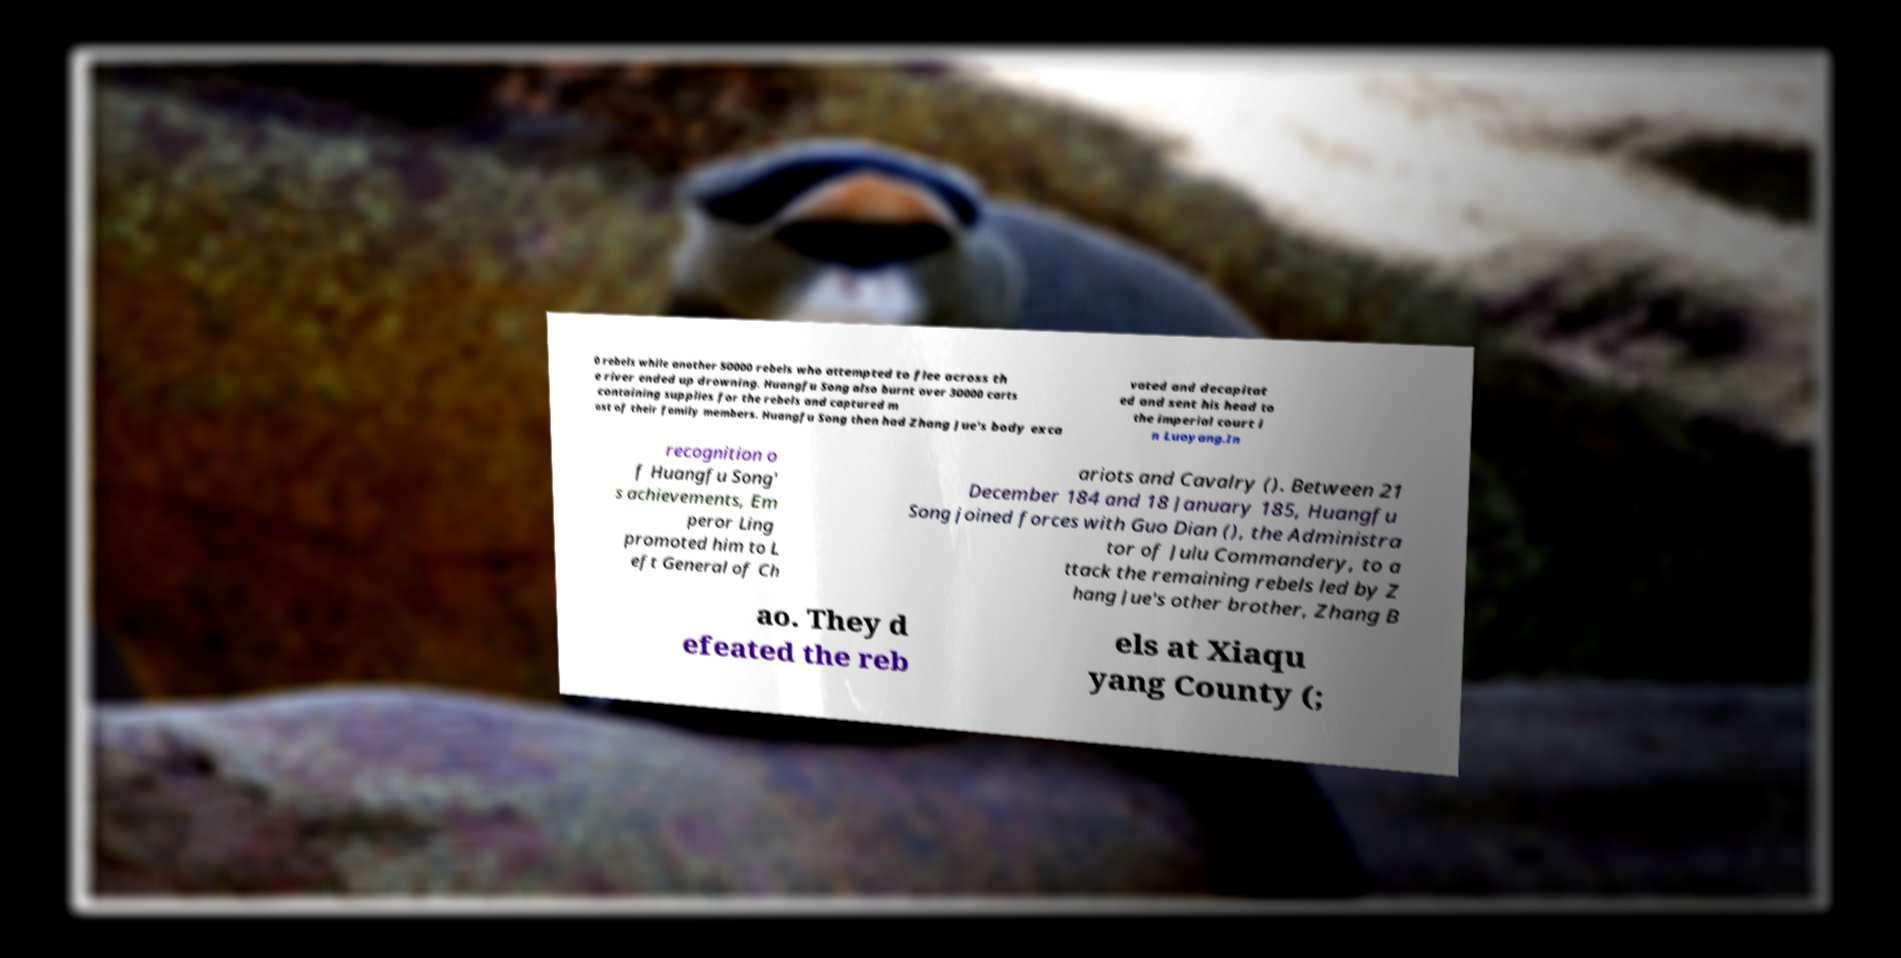Can you read and provide the text displayed in the image?This photo seems to have some interesting text. Can you extract and type it out for me? 0 rebels while another 50000 rebels who attempted to flee across th e river ended up drowning. Huangfu Song also burnt over 30000 carts containing supplies for the rebels and captured m ost of their family members. Huangfu Song then had Zhang Jue's body exca vated and decapitat ed and sent his head to the imperial court i n Luoyang.In recognition o f Huangfu Song' s achievements, Em peror Ling promoted him to L eft General of Ch ariots and Cavalry (). Between 21 December 184 and 18 January 185, Huangfu Song joined forces with Guo Dian (), the Administra tor of Julu Commandery, to a ttack the remaining rebels led by Z hang Jue's other brother, Zhang B ao. They d efeated the reb els at Xiaqu yang County (; 